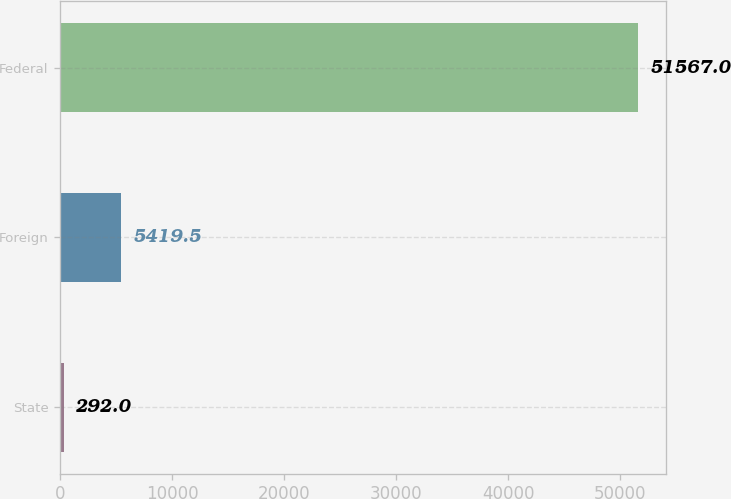Convert chart. <chart><loc_0><loc_0><loc_500><loc_500><bar_chart><fcel>State<fcel>Foreign<fcel>Federal<nl><fcel>292<fcel>5419.5<fcel>51567<nl></chart> 